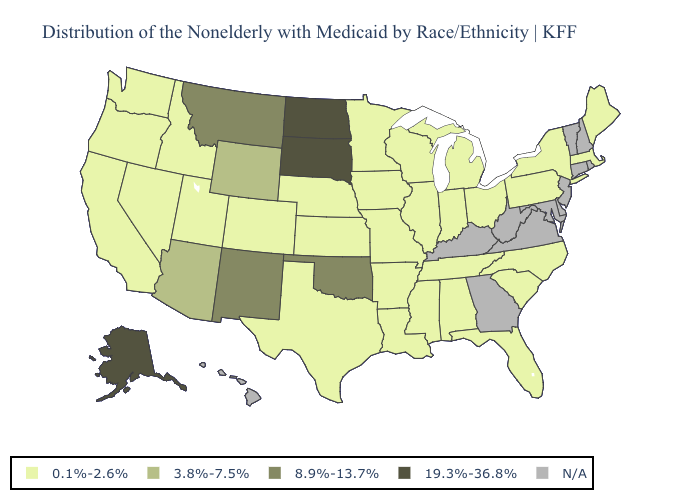What is the highest value in the USA?
Quick response, please. 19.3%-36.8%. What is the value of Arizona?
Be succinct. 3.8%-7.5%. What is the value of Nebraska?
Answer briefly. 0.1%-2.6%. Does New Mexico have the lowest value in the USA?
Write a very short answer. No. Name the states that have a value in the range N/A?
Quick response, please. Connecticut, Delaware, Georgia, Hawaii, Kentucky, Maryland, New Hampshire, New Jersey, Rhode Island, Vermont, Virginia, West Virginia. What is the lowest value in states that border Colorado?
Be succinct. 0.1%-2.6%. Among the states that border Colorado , which have the lowest value?
Quick response, please. Kansas, Nebraska, Utah. What is the value of Idaho?
Be succinct. 0.1%-2.6%. Does Alaska have the lowest value in the USA?
Be succinct. No. What is the value of Minnesota?
Keep it brief. 0.1%-2.6%. Name the states that have a value in the range 8.9%-13.7%?
Be succinct. Montana, New Mexico, Oklahoma. What is the value of Pennsylvania?
Write a very short answer. 0.1%-2.6%. 